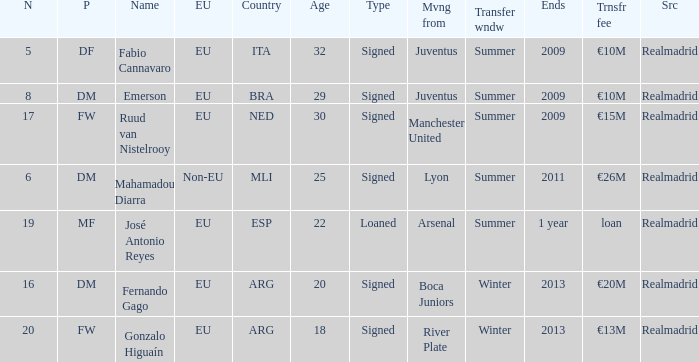How many numbers are ending in 1 year? 1.0. 